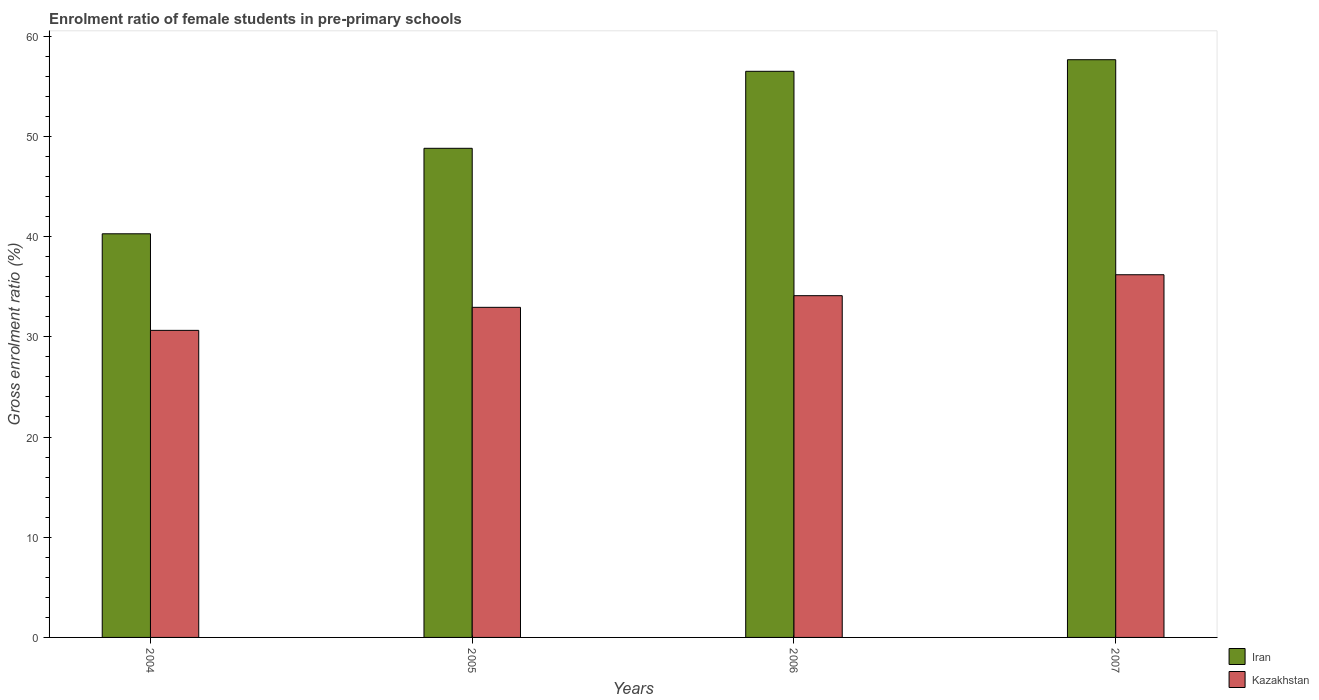How many different coloured bars are there?
Your response must be concise. 2. How many groups of bars are there?
Give a very brief answer. 4. Are the number of bars per tick equal to the number of legend labels?
Your response must be concise. Yes. Are the number of bars on each tick of the X-axis equal?
Keep it short and to the point. Yes. How many bars are there on the 1st tick from the left?
Your response must be concise. 2. What is the label of the 4th group of bars from the left?
Offer a terse response. 2007. What is the enrolment ratio of female students in pre-primary schools in Iran in 2004?
Give a very brief answer. 40.28. Across all years, what is the maximum enrolment ratio of female students in pre-primary schools in Kazakhstan?
Provide a short and direct response. 36.19. Across all years, what is the minimum enrolment ratio of female students in pre-primary schools in Kazakhstan?
Your answer should be very brief. 30.64. In which year was the enrolment ratio of female students in pre-primary schools in Iran maximum?
Offer a terse response. 2007. What is the total enrolment ratio of female students in pre-primary schools in Iran in the graph?
Your answer should be compact. 203.23. What is the difference between the enrolment ratio of female students in pre-primary schools in Kazakhstan in 2005 and that in 2007?
Keep it short and to the point. -3.25. What is the difference between the enrolment ratio of female students in pre-primary schools in Kazakhstan in 2007 and the enrolment ratio of female students in pre-primary schools in Iran in 2004?
Your answer should be compact. -4.09. What is the average enrolment ratio of female students in pre-primary schools in Iran per year?
Keep it short and to the point. 50.81. In the year 2007, what is the difference between the enrolment ratio of female students in pre-primary schools in Iran and enrolment ratio of female students in pre-primary schools in Kazakhstan?
Provide a succinct answer. 21.46. In how many years, is the enrolment ratio of female students in pre-primary schools in Kazakhstan greater than 48 %?
Offer a very short reply. 0. What is the ratio of the enrolment ratio of female students in pre-primary schools in Kazakhstan in 2005 to that in 2007?
Your response must be concise. 0.91. What is the difference between the highest and the second highest enrolment ratio of female students in pre-primary schools in Kazakhstan?
Make the answer very short. 2.09. What is the difference between the highest and the lowest enrolment ratio of female students in pre-primary schools in Kazakhstan?
Ensure brevity in your answer.  5.55. In how many years, is the enrolment ratio of female students in pre-primary schools in Kazakhstan greater than the average enrolment ratio of female students in pre-primary schools in Kazakhstan taken over all years?
Your answer should be very brief. 2. Is the sum of the enrolment ratio of female students in pre-primary schools in Iran in 2005 and 2007 greater than the maximum enrolment ratio of female students in pre-primary schools in Kazakhstan across all years?
Provide a short and direct response. Yes. What does the 2nd bar from the left in 2005 represents?
Offer a terse response. Kazakhstan. What does the 2nd bar from the right in 2005 represents?
Provide a succinct answer. Iran. How many years are there in the graph?
Provide a short and direct response. 4. How many legend labels are there?
Ensure brevity in your answer.  2. What is the title of the graph?
Provide a succinct answer. Enrolment ratio of female students in pre-primary schools. What is the label or title of the Y-axis?
Offer a very short reply. Gross enrolment ratio (%). What is the Gross enrolment ratio (%) in Iran in 2004?
Your response must be concise. 40.28. What is the Gross enrolment ratio (%) in Kazakhstan in 2004?
Your response must be concise. 30.64. What is the Gross enrolment ratio (%) of Iran in 2005?
Make the answer very short. 48.81. What is the Gross enrolment ratio (%) in Kazakhstan in 2005?
Give a very brief answer. 32.94. What is the Gross enrolment ratio (%) of Iran in 2006?
Give a very brief answer. 56.49. What is the Gross enrolment ratio (%) of Kazakhstan in 2006?
Give a very brief answer. 34.1. What is the Gross enrolment ratio (%) of Iran in 2007?
Offer a very short reply. 57.65. What is the Gross enrolment ratio (%) of Kazakhstan in 2007?
Ensure brevity in your answer.  36.19. Across all years, what is the maximum Gross enrolment ratio (%) of Iran?
Your answer should be very brief. 57.65. Across all years, what is the maximum Gross enrolment ratio (%) in Kazakhstan?
Provide a short and direct response. 36.19. Across all years, what is the minimum Gross enrolment ratio (%) of Iran?
Provide a short and direct response. 40.28. Across all years, what is the minimum Gross enrolment ratio (%) of Kazakhstan?
Your response must be concise. 30.64. What is the total Gross enrolment ratio (%) of Iran in the graph?
Provide a succinct answer. 203.23. What is the total Gross enrolment ratio (%) in Kazakhstan in the graph?
Your answer should be very brief. 133.88. What is the difference between the Gross enrolment ratio (%) of Iran in 2004 and that in 2005?
Offer a very short reply. -8.53. What is the difference between the Gross enrolment ratio (%) of Kazakhstan in 2004 and that in 2005?
Give a very brief answer. -2.3. What is the difference between the Gross enrolment ratio (%) in Iran in 2004 and that in 2006?
Ensure brevity in your answer.  -16.21. What is the difference between the Gross enrolment ratio (%) of Kazakhstan in 2004 and that in 2006?
Provide a succinct answer. -3.46. What is the difference between the Gross enrolment ratio (%) of Iran in 2004 and that in 2007?
Your answer should be very brief. -17.37. What is the difference between the Gross enrolment ratio (%) in Kazakhstan in 2004 and that in 2007?
Your answer should be very brief. -5.55. What is the difference between the Gross enrolment ratio (%) of Iran in 2005 and that in 2006?
Provide a succinct answer. -7.68. What is the difference between the Gross enrolment ratio (%) in Kazakhstan in 2005 and that in 2006?
Ensure brevity in your answer.  -1.16. What is the difference between the Gross enrolment ratio (%) of Iran in 2005 and that in 2007?
Offer a very short reply. -8.84. What is the difference between the Gross enrolment ratio (%) in Kazakhstan in 2005 and that in 2007?
Offer a terse response. -3.25. What is the difference between the Gross enrolment ratio (%) of Iran in 2006 and that in 2007?
Make the answer very short. -1.16. What is the difference between the Gross enrolment ratio (%) in Kazakhstan in 2006 and that in 2007?
Your answer should be very brief. -2.09. What is the difference between the Gross enrolment ratio (%) in Iran in 2004 and the Gross enrolment ratio (%) in Kazakhstan in 2005?
Provide a succinct answer. 7.34. What is the difference between the Gross enrolment ratio (%) in Iran in 2004 and the Gross enrolment ratio (%) in Kazakhstan in 2006?
Offer a terse response. 6.17. What is the difference between the Gross enrolment ratio (%) in Iran in 2004 and the Gross enrolment ratio (%) in Kazakhstan in 2007?
Provide a succinct answer. 4.09. What is the difference between the Gross enrolment ratio (%) in Iran in 2005 and the Gross enrolment ratio (%) in Kazakhstan in 2006?
Offer a very short reply. 14.71. What is the difference between the Gross enrolment ratio (%) in Iran in 2005 and the Gross enrolment ratio (%) in Kazakhstan in 2007?
Your response must be concise. 12.62. What is the difference between the Gross enrolment ratio (%) in Iran in 2006 and the Gross enrolment ratio (%) in Kazakhstan in 2007?
Offer a terse response. 20.3. What is the average Gross enrolment ratio (%) in Iran per year?
Provide a short and direct response. 50.81. What is the average Gross enrolment ratio (%) of Kazakhstan per year?
Provide a short and direct response. 33.47. In the year 2004, what is the difference between the Gross enrolment ratio (%) of Iran and Gross enrolment ratio (%) of Kazakhstan?
Your answer should be compact. 9.64. In the year 2005, what is the difference between the Gross enrolment ratio (%) in Iran and Gross enrolment ratio (%) in Kazakhstan?
Give a very brief answer. 15.87. In the year 2006, what is the difference between the Gross enrolment ratio (%) in Iran and Gross enrolment ratio (%) in Kazakhstan?
Keep it short and to the point. 22.39. In the year 2007, what is the difference between the Gross enrolment ratio (%) in Iran and Gross enrolment ratio (%) in Kazakhstan?
Offer a very short reply. 21.46. What is the ratio of the Gross enrolment ratio (%) of Iran in 2004 to that in 2005?
Give a very brief answer. 0.83. What is the ratio of the Gross enrolment ratio (%) in Kazakhstan in 2004 to that in 2005?
Give a very brief answer. 0.93. What is the ratio of the Gross enrolment ratio (%) in Iran in 2004 to that in 2006?
Keep it short and to the point. 0.71. What is the ratio of the Gross enrolment ratio (%) of Kazakhstan in 2004 to that in 2006?
Ensure brevity in your answer.  0.9. What is the ratio of the Gross enrolment ratio (%) of Iran in 2004 to that in 2007?
Offer a very short reply. 0.7. What is the ratio of the Gross enrolment ratio (%) of Kazakhstan in 2004 to that in 2007?
Offer a terse response. 0.85. What is the ratio of the Gross enrolment ratio (%) of Iran in 2005 to that in 2006?
Offer a very short reply. 0.86. What is the ratio of the Gross enrolment ratio (%) in Kazakhstan in 2005 to that in 2006?
Your answer should be very brief. 0.97. What is the ratio of the Gross enrolment ratio (%) in Iran in 2005 to that in 2007?
Offer a very short reply. 0.85. What is the ratio of the Gross enrolment ratio (%) in Kazakhstan in 2005 to that in 2007?
Your answer should be compact. 0.91. What is the ratio of the Gross enrolment ratio (%) of Iran in 2006 to that in 2007?
Your response must be concise. 0.98. What is the ratio of the Gross enrolment ratio (%) in Kazakhstan in 2006 to that in 2007?
Offer a terse response. 0.94. What is the difference between the highest and the second highest Gross enrolment ratio (%) of Iran?
Give a very brief answer. 1.16. What is the difference between the highest and the second highest Gross enrolment ratio (%) in Kazakhstan?
Offer a very short reply. 2.09. What is the difference between the highest and the lowest Gross enrolment ratio (%) of Iran?
Offer a terse response. 17.37. What is the difference between the highest and the lowest Gross enrolment ratio (%) of Kazakhstan?
Give a very brief answer. 5.55. 